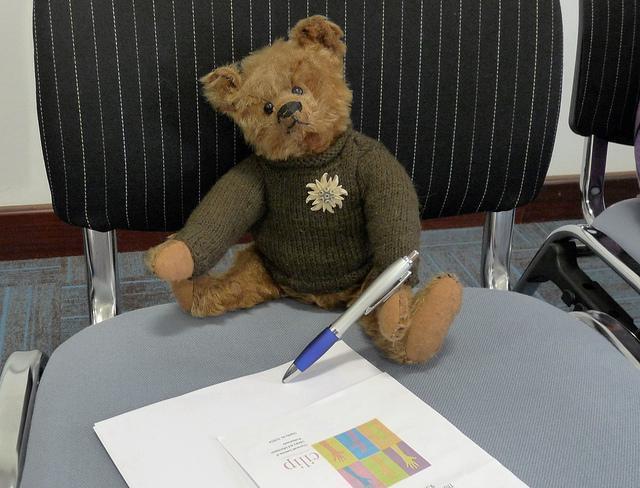What is the pen used to do on the paper?
Make your selection and explain in format: 'Answer: answer
Rationale: rationale.'
Options: Stab, write, poke, massage. Answer: write.
Rationale: A pen is resting on a the corner of a piece of paper. 